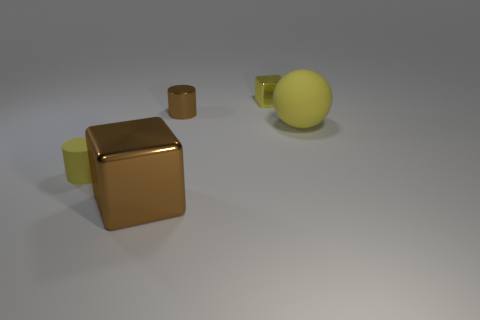There is a ball that is the same color as the tiny rubber cylinder; what is its size?
Provide a short and direct response. Large. Are the cylinder that is right of the small yellow matte cylinder and the big brown block made of the same material?
Your answer should be compact. Yes. What material is the yellow thing that is the same shape as the large brown metal object?
Give a very brief answer. Metal. There is a ball that is the same color as the small cube; what material is it?
Offer a very short reply. Rubber. Are there fewer large matte things than small yellow objects?
Provide a succinct answer. Yes. Does the metallic block to the right of the shiny cylinder have the same color as the big metallic thing?
Ensure brevity in your answer.  No. There is a tiny thing that is the same material as the ball; what color is it?
Your answer should be compact. Yellow. Do the rubber cylinder and the metallic cylinder have the same size?
Your answer should be very brief. Yes. What is the small yellow cube made of?
Provide a succinct answer. Metal. There is a object that is the same size as the ball; what is its material?
Your answer should be compact. Metal. 